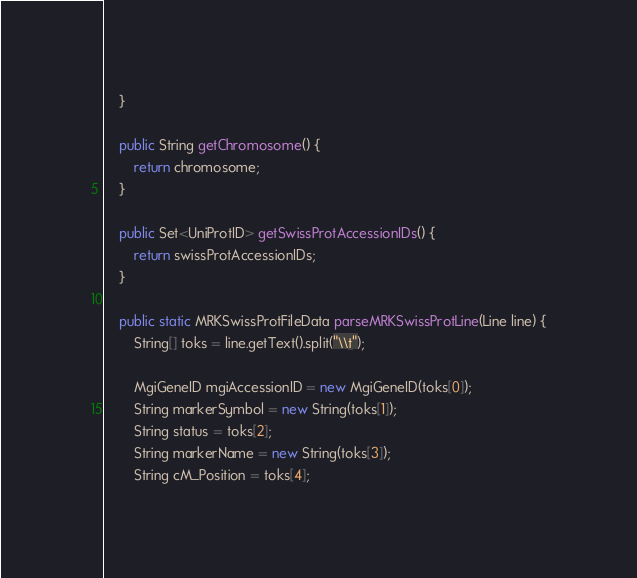Convert code to text. <code><loc_0><loc_0><loc_500><loc_500><_Java_>	}

	public String getChromosome() {
		return chromosome;
	}

	public Set<UniProtID> getSwissProtAccessionIDs() {
		return swissProtAccessionIDs;
	}

	public static MRKSwissProtFileData parseMRKSwissProtLine(Line line) {
		String[] toks = line.getText().split("\\t");

		MgiGeneID mgiAccessionID = new MgiGeneID(toks[0]);
		String markerSymbol = new String(toks[1]);
		String status = toks[2];
		String markerName = new String(toks[3]);
		String cM_Position = toks[4];</code> 